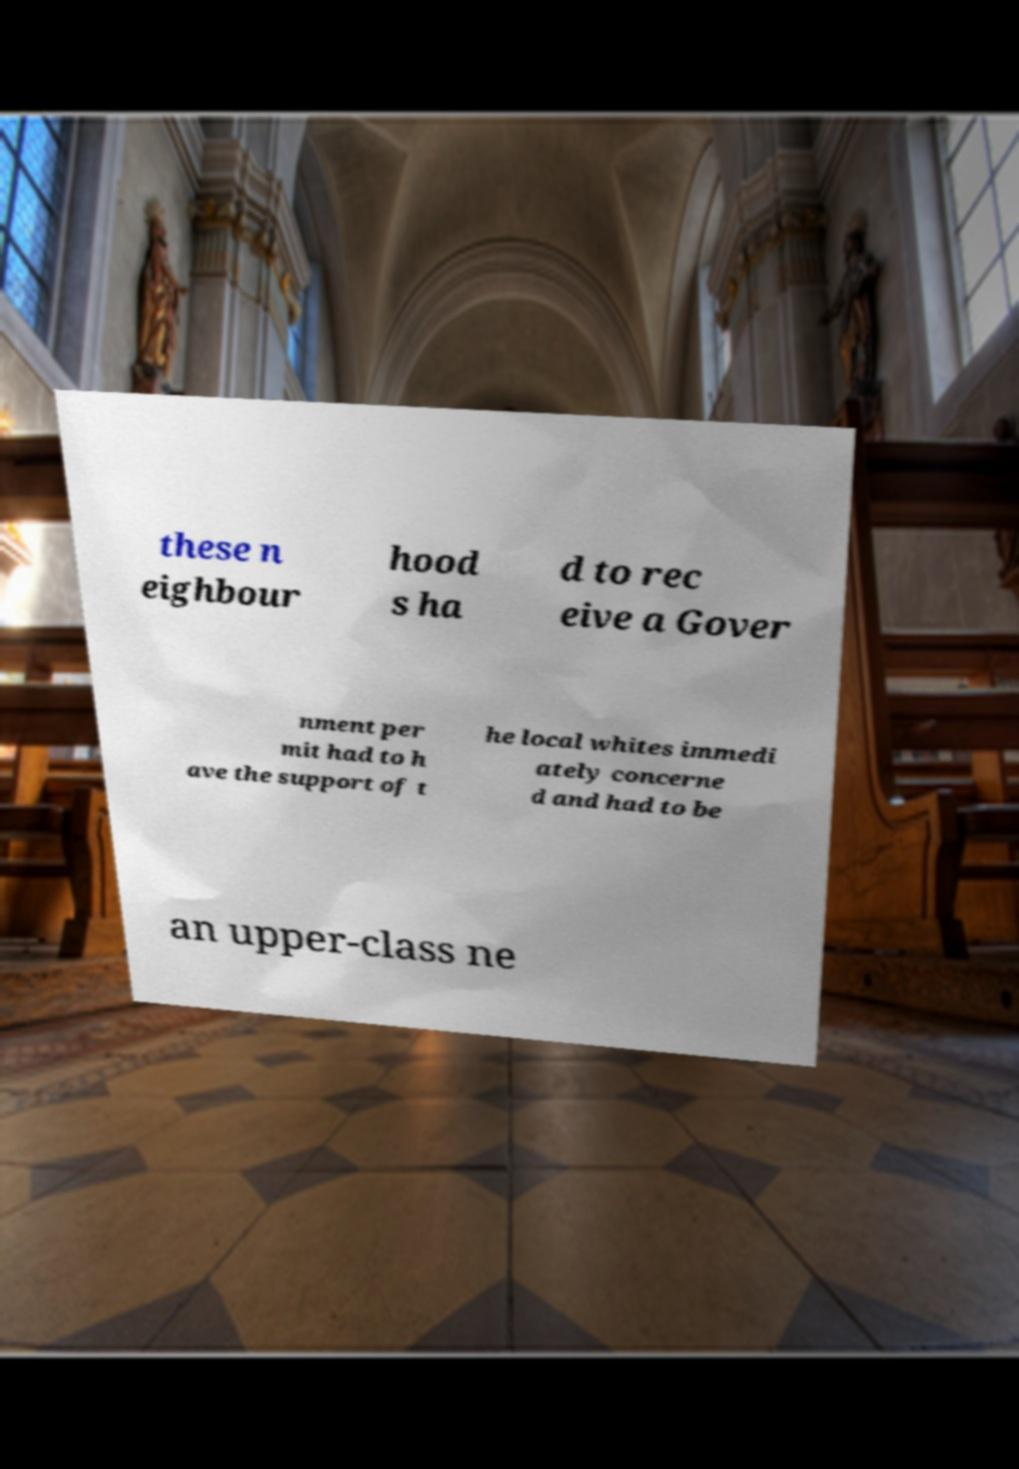Could you extract and type out the text from this image? these n eighbour hood s ha d to rec eive a Gover nment per mit had to h ave the support of t he local whites immedi ately concerne d and had to be an upper-class ne 